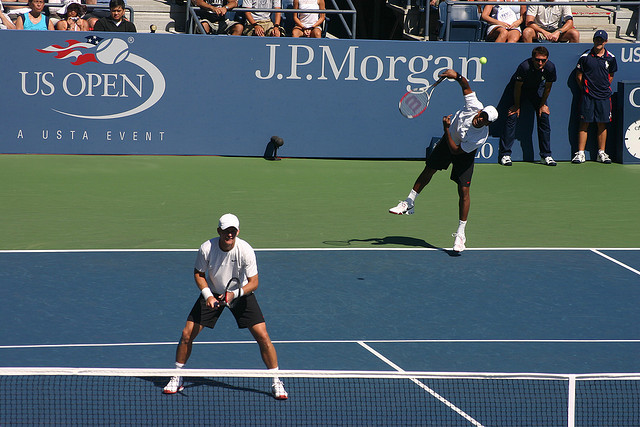Read and extract the text from this image. US OPEN A USTA EVENT C us 10 J.P. Morgan 